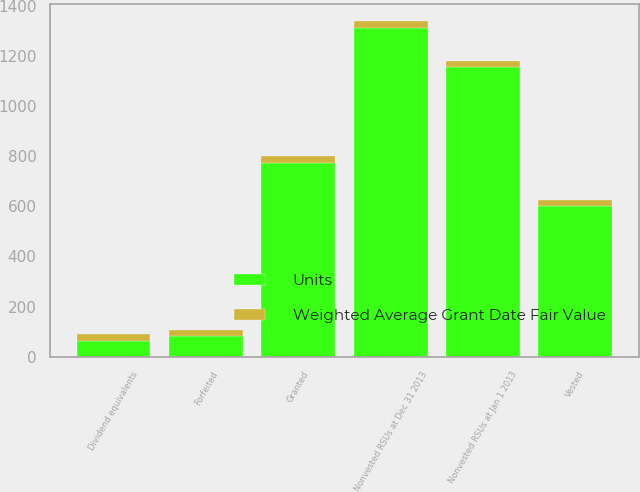<chart> <loc_0><loc_0><loc_500><loc_500><stacked_bar_chart><ecel><fcel>Nonvested RSUs at Jan 1 2013<fcel>Granted<fcel>Forfeited<fcel>Vested<fcel>Dividend equivalents<fcel>Nonvested RSUs at Dec 31 2013<nl><fcel>Units<fcel>1155<fcel>774<fcel>81<fcel>600<fcel>64<fcel>1312<nl><fcel>Weighted Average Grant Date Fair Value<fcel>25.41<fcel>27.65<fcel>26.32<fcel>23.62<fcel>26.11<fcel>27.53<nl></chart> 